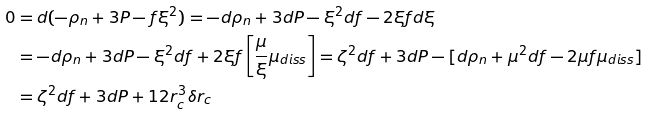<formula> <loc_0><loc_0><loc_500><loc_500>0 & = d ( - \rho _ { n } + 3 P - f \xi ^ { 2 } ) = - d \rho _ { n } + 3 d P - \xi ^ { 2 } d f - 2 \xi f d \xi \\ & = - d \rho _ { n } + 3 d P - \xi ^ { 2 } d f + 2 \xi f \left [ \frac { \mu } { \xi } \mu _ { d i s s } \right ] = \zeta ^ { 2 } d f + 3 d P - [ d \rho _ { n } + \mu ^ { 2 } d f - 2 \mu f \mu _ { d i s s } ] \\ & = \zeta ^ { 2 } d f + 3 d P + 1 2 r _ { c } ^ { 3 } \delta r _ { c }</formula> 